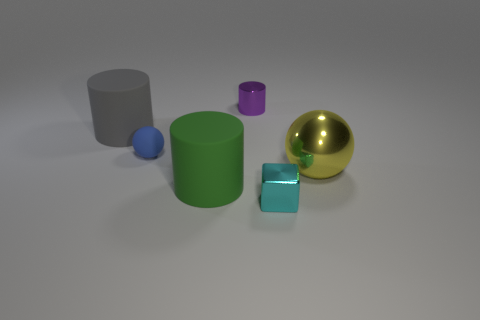Subtract all purple shiny cylinders. How many cylinders are left? 2 Subtract all green cylinders. How many cylinders are left? 2 Add 2 small matte spheres. How many objects exist? 8 Subtract all cubes. How many objects are left? 5 Subtract all yellow balls. Subtract all red cubes. How many balls are left? 1 Subtract all small yellow metallic objects. Subtract all tiny purple metallic cylinders. How many objects are left? 5 Add 4 big shiny things. How many big shiny things are left? 5 Add 3 blue shiny cylinders. How many blue shiny cylinders exist? 3 Subtract 0 red blocks. How many objects are left? 6 